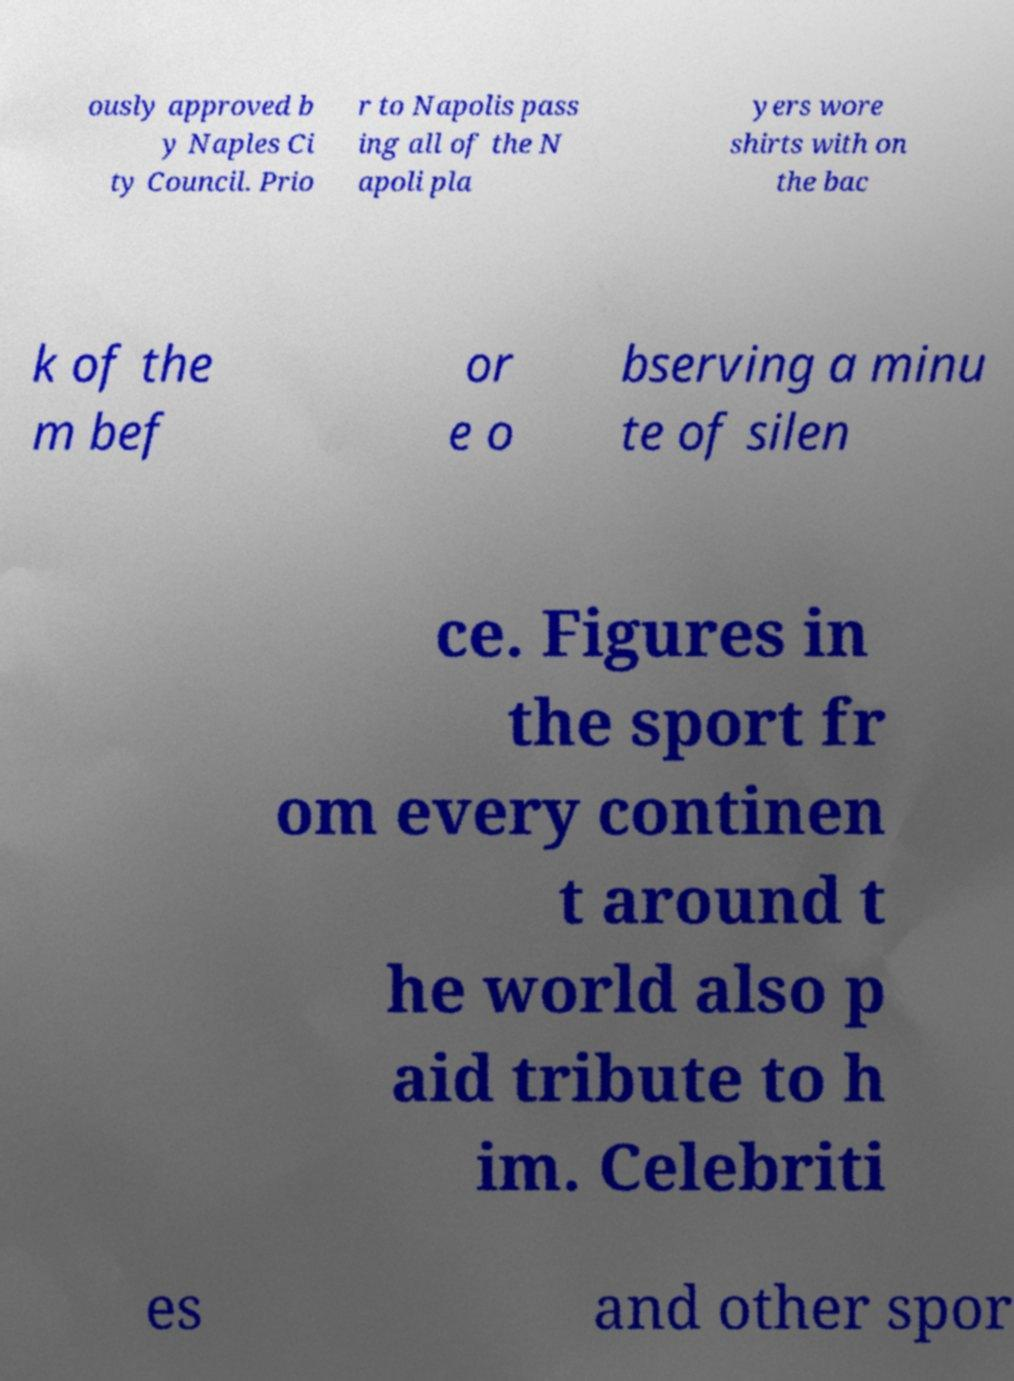I need the written content from this picture converted into text. Can you do that? ously approved b y Naples Ci ty Council. Prio r to Napolis pass ing all of the N apoli pla yers wore shirts with on the bac k of the m bef or e o bserving a minu te of silen ce. Figures in the sport fr om every continen t around t he world also p aid tribute to h im. Celebriti es and other spor 